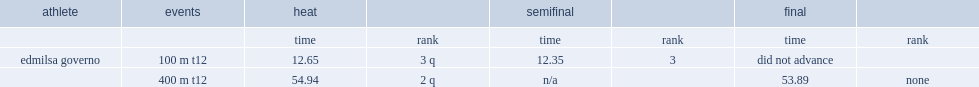What was the result that edmilsa governo got in the final in the 400 m t12. 53.89. 